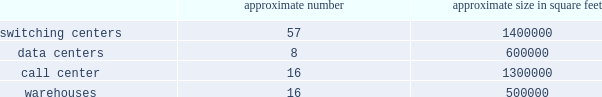Does not believe are in our and our stockholders 2019 best interest .
The rights plan is intended to protect stockholders in the event of an unfair or coercive offer to acquire the company and to provide our board of directors with adequate time to evaluate unsolicited offers .
The rights plan may prevent or make takeovers or unsolicited corporate transactions with respect to our company more difficult , even if stockholders may consider such transactions favorable , possibly including transactions in which stockholders might otherwise receive a premium for their shares .
Item 1b .
Unresolved staff comments item 2 .
Properties as of december 31 , 2016 , our significant properties used in connection with switching centers , data centers , call centers and warehouses were as follows: .
As of december 31 , 2016 , we leased approximately 60000 cell sites .
As of december 31 , 2016 , we leased approximately 2000 t-mobile and metropcs retail locations , including stores and kiosks ranging in size from approximately 100 square feet to 17000 square feet .
We currently lease office space totaling approximately 950000 square feet for our corporate headquarters in bellevue , washington .
We use these offices for engineering and administrative purposes .
We also lease space throughout the u.s. , totaling approximately 1200000 square feet as of december 31 , 2016 , for use by our regional offices primarily for administrative , engineering and sales purposes .
Item 3 .
Legal proceedings see note 12 2013 commitments and contingencies of the notes to the consolidated financial statements included in part ii , item 8 of this form 10-k for information regarding certain legal proceedings in which we are involved .
Item 4 .
Mine safety disclosures part ii .
Item 5 .
Market for registrant 2019s common equity , related stockholder matters and issuer purchases of equity securities market information our common stock is traded on the nasdaq global select market of the nasdaq stock market llc ( 201cnasdaq 201d ) under the symbol 201ctmus . 201d as of december 31 , 2016 , there were 309 registered stockholders of record of our common stock , but we estimate the total number of stockholders to be much higher as a number of our shares are held by brokers or dealers for their customers in street name. .
As of 2016 , what was the average size of switching centers? 
Computations: (1400000 / 57)
Answer: 24561.40351. 